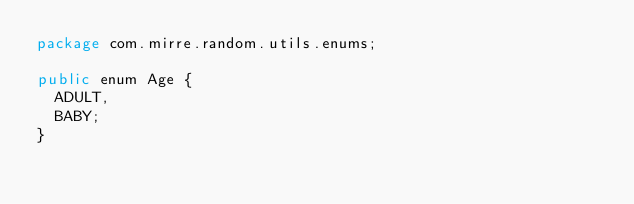<code> <loc_0><loc_0><loc_500><loc_500><_Java_>package com.mirre.random.utils.enums;

public enum Age {
	ADULT, 
	BABY;
}
</code> 